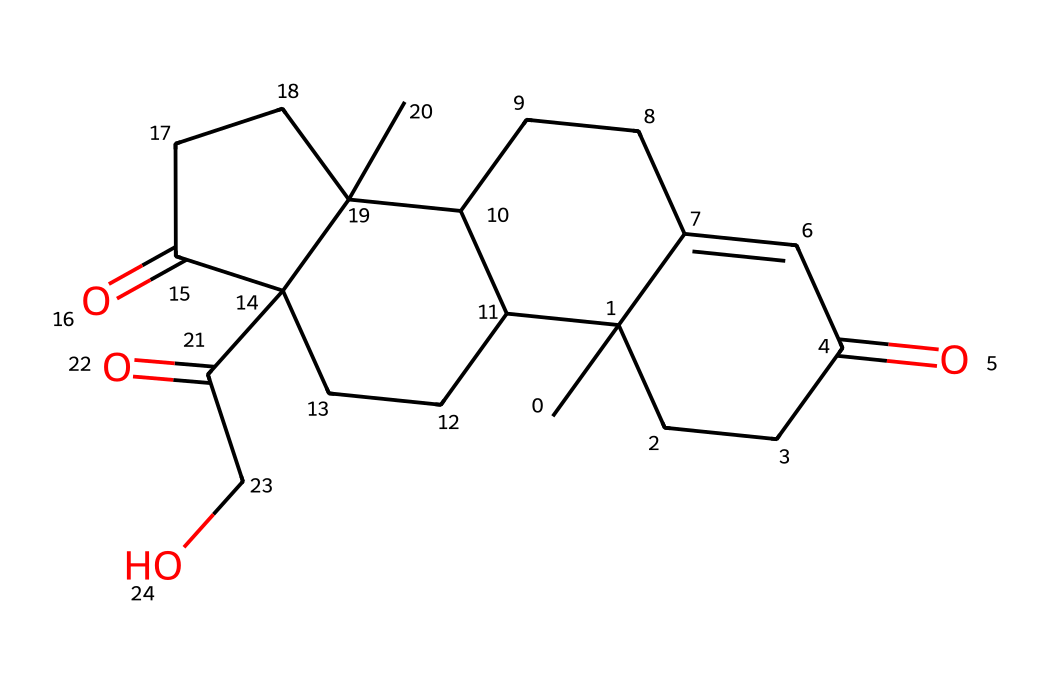how many carbon atoms are there in cortisol? By counting each 'C' in the SMILES notation, we find that there are 21 carbon atoms.
Answer: 21 what is the main functional group in cortisol? The structure contains ketones indicated by the C(=O) notation, which is the defining functional group here.
Answer: ketone how many double bonds are present in cortisol? By analyzing the structure, there are 4 double bonds in total, indicated by the presence of '=' signs in the SMILES.
Answer: 4 is cortisol a steroid? The structure features a four-ring core structure typical of steroids, confirming that cortisol is indeed a steroid hormone.
Answer: yes what is the molecular weight of cortisol? By calculating the total weight of all the atoms in the compound based on the chemical formula derived from the SMILES, cortisol has a molecular weight of approximately 362.46 g/mol.
Answer: 362.46 which part of cortisol is primarily responsible for stress regulation? The overall structure of cortisol, especially the steroid framework and the ketone groups, plays a key role in its function for stress regulation.
Answer: steroid framework how does the structural complexity of cortisol relate to its biological function? The complex arrangement of rings and functional groups in cortisol allows it to interact effectively with hormone receptors, enabling its regulatory role in stress.
Answer: effective receptor interaction 